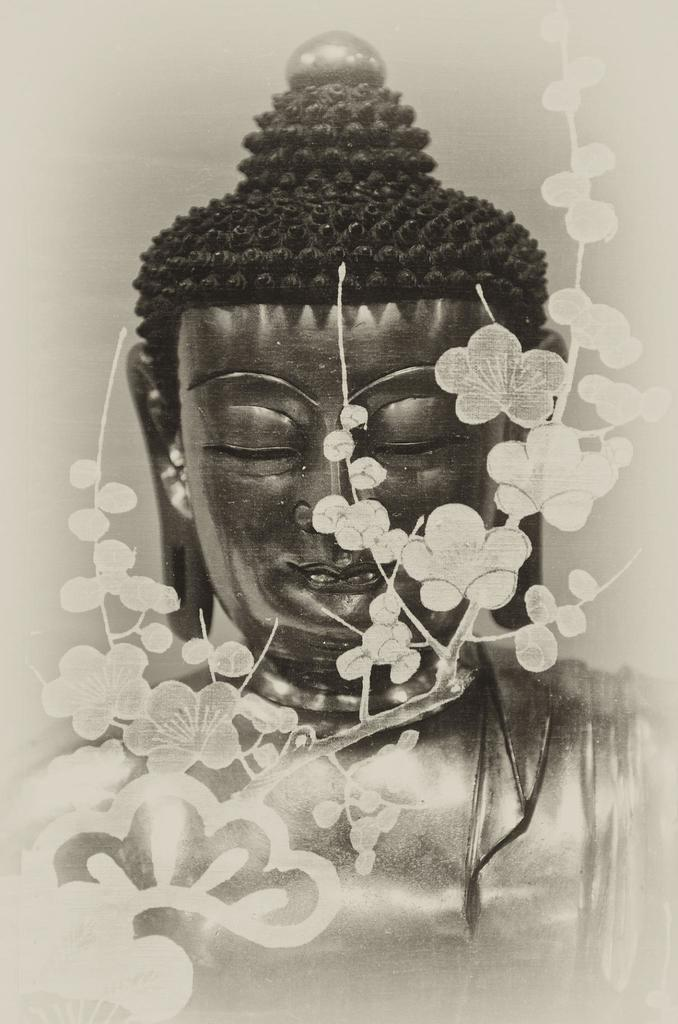How has the image been altered? The image is edited. What is the main subject of the image? There is a statue of the Buddha in the image. What other elements are present in the image? There are flowers in the image. Can you hear the whistle in the image? There is no whistle present in the image, as it is a visual medium and does not contain sound. 